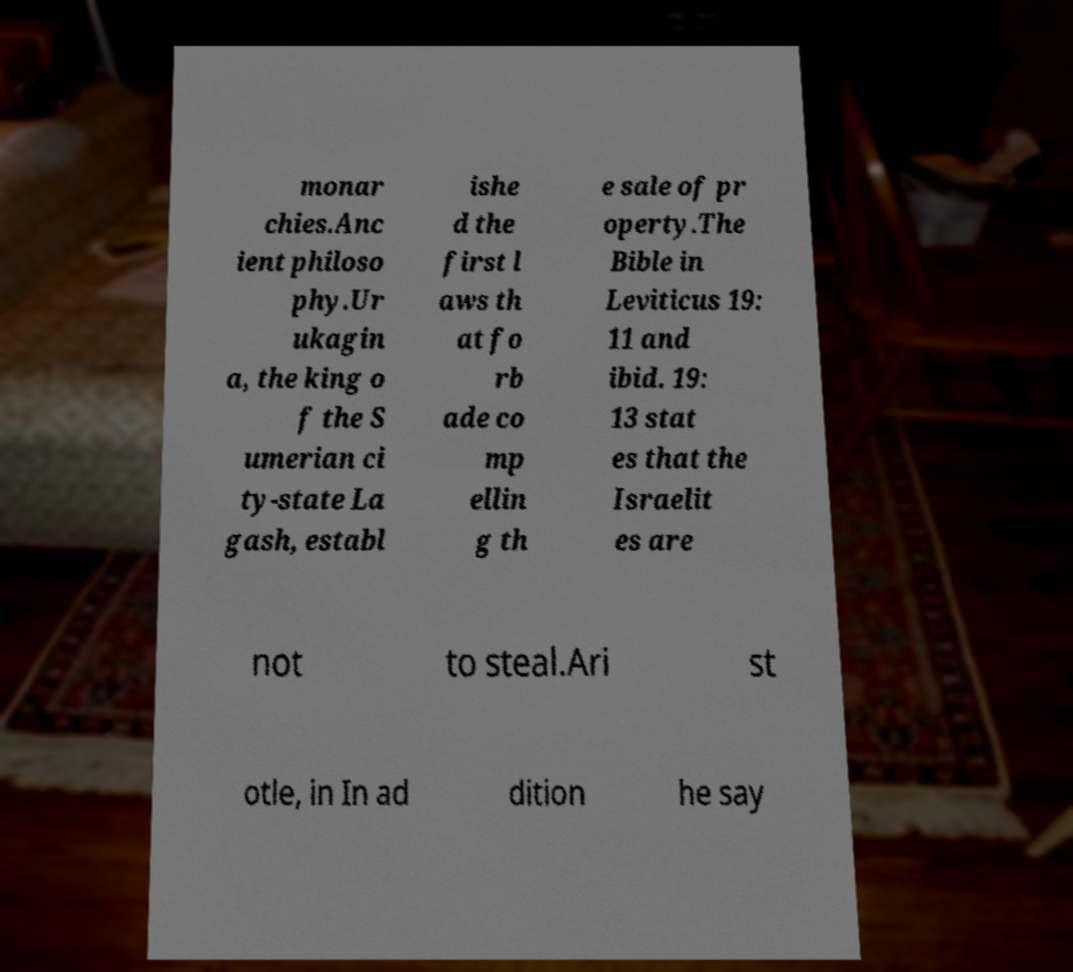Please identify and transcribe the text found in this image. monar chies.Anc ient philoso phy.Ur ukagin a, the king o f the S umerian ci ty-state La gash, establ ishe d the first l aws th at fo rb ade co mp ellin g th e sale of pr operty.The Bible in Leviticus 19: 11 and ibid. 19: 13 stat es that the Israelit es are not to steal.Ari st otle, in In ad dition he say 